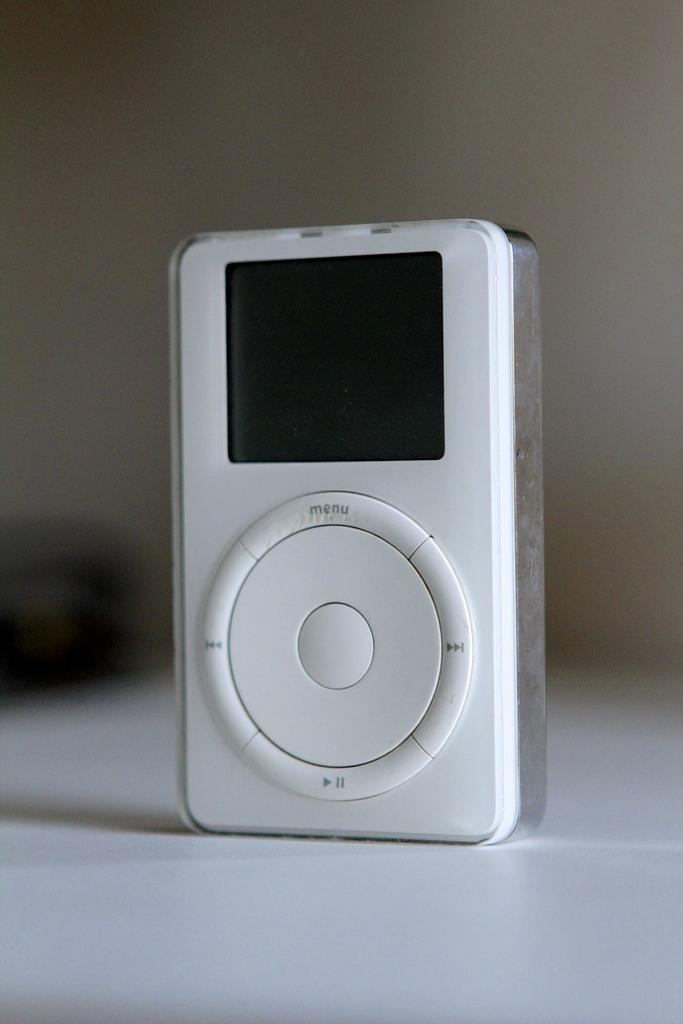What is the main subject in the middle of the image? There is a musical device in the middle of the image. Can you describe the background of the image? The background of the image is blurry. What type of net can be seen catching a van in the image? There is no net or van present in the image. Can you describe the running activity in the image? There is no running activity depicted in the image. 